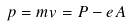<formula> <loc_0><loc_0><loc_500><loc_500>p = m v = P - e A</formula> 